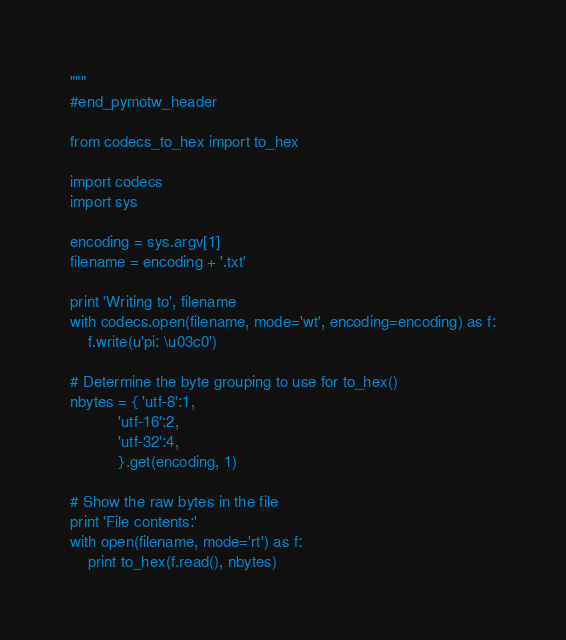<code> <loc_0><loc_0><loc_500><loc_500><_Python_>"""
#end_pymotw_header

from codecs_to_hex import to_hex

import codecs
import sys

encoding = sys.argv[1]
filename = encoding + '.txt'

print 'Writing to', filename
with codecs.open(filename, mode='wt', encoding=encoding) as f:
    f.write(u'pi: \u03c0')

# Determine the byte grouping to use for to_hex()
nbytes = { 'utf-8':1,
           'utf-16':2,
           'utf-32':4,
           }.get(encoding, 1) 

# Show the raw bytes in the file
print 'File contents:'
with open(filename, mode='rt') as f:
    print to_hex(f.read(), nbytes)
</code> 